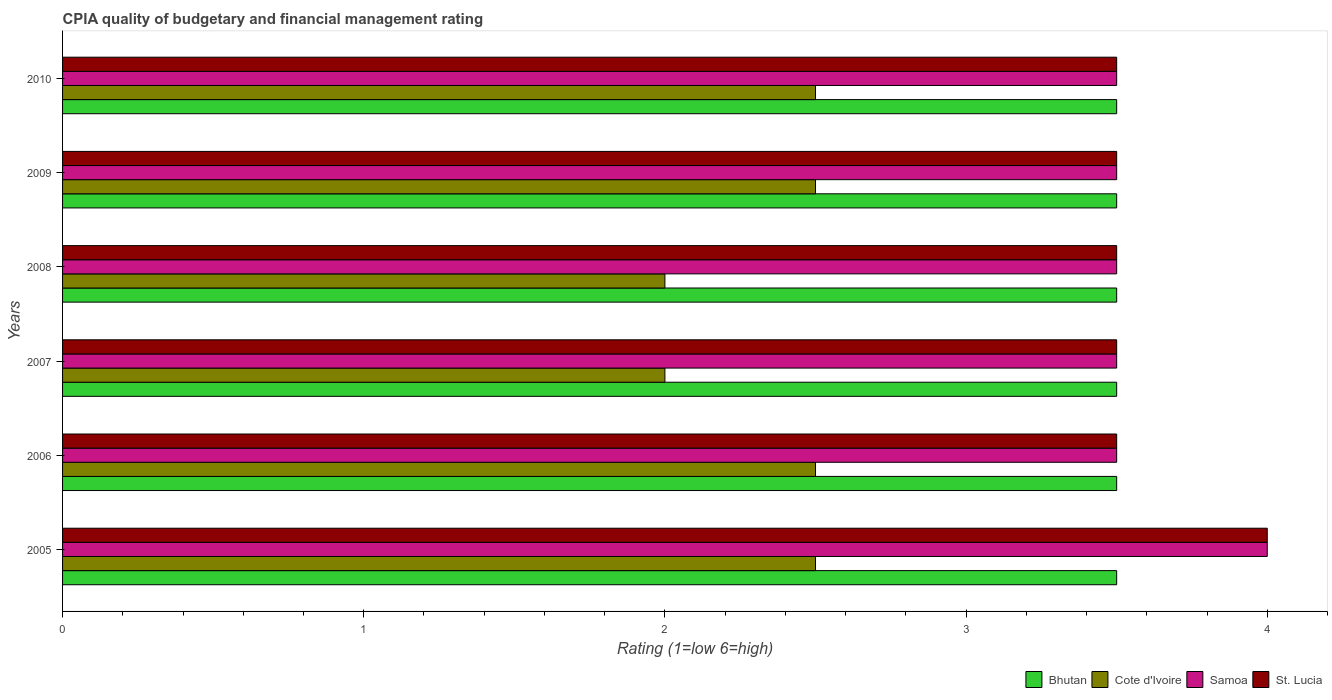How many different coloured bars are there?
Your answer should be compact. 4. How many groups of bars are there?
Provide a short and direct response. 6. Are the number of bars per tick equal to the number of legend labels?
Your answer should be very brief. Yes. Are the number of bars on each tick of the Y-axis equal?
Your answer should be compact. Yes. How many bars are there on the 5th tick from the top?
Your answer should be compact. 4. In how many cases, is the number of bars for a given year not equal to the number of legend labels?
Provide a short and direct response. 0. In which year was the CPIA rating in Cote d'Ivoire maximum?
Your answer should be very brief. 2005. In which year was the CPIA rating in Bhutan minimum?
Your response must be concise. 2005. What is the total CPIA rating in Bhutan in the graph?
Provide a short and direct response. 21. What is the average CPIA rating in St. Lucia per year?
Your response must be concise. 3.58. In how many years, is the CPIA rating in Bhutan greater than 1.2 ?
Keep it short and to the point. 6. What is the ratio of the CPIA rating in Samoa in 2005 to that in 2008?
Keep it short and to the point. 1.14. Is the CPIA rating in Samoa in 2006 less than that in 2008?
Provide a short and direct response. No. Is the difference between the CPIA rating in Bhutan in 2009 and 2010 greater than the difference between the CPIA rating in Samoa in 2009 and 2010?
Give a very brief answer. No. What is the difference between the highest and the second highest CPIA rating in Bhutan?
Your answer should be very brief. 0. In how many years, is the CPIA rating in Samoa greater than the average CPIA rating in Samoa taken over all years?
Offer a very short reply. 1. Is the sum of the CPIA rating in St. Lucia in 2009 and 2010 greater than the maximum CPIA rating in Bhutan across all years?
Give a very brief answer. Yes. What does the 3rd bar from the top in 2009 represents?
Offer a terse response. Cote d'Ivoire. What does the 3rd bar from the bottom in 2006 represents?
Your response must be concise. Samoa. Is it the case that in every year, the sum of the CPIA rating in Samoa and CPIA rating in St. Lucia is greater than the CPIA rating in Bhutan?
Keep it short and to the point. Yes. How many bars are there?
Offer a very short reply. 24. Are all the bars in the graph horizontal?
Your answer should be very brief. Yes. What is the difference between two consecutive major ticks on the X-axis?
Ensure brevity in your answer.  1. Are the values on the major ticks of X-axis written in scientific E-notation?
Ensure brevity in your answer.  No. Where does the legend appear in the graph?
Ensure brevity in your answer.  Bottom right. How many legend labels are there?
Offer a very short reply. 4. What is the title of the graph?
Your response must be concise. CPIA quality of budgetary and financial management rating. Does "Korea (Republic)" appear as one of the legend labels in the graph?
Offer a very short reply. No. What is the Rating (1=low 6=high) in Bhutan in 2005?
Your answer should be very brief. 3.5. What is the Rating (1=low 6=high) in Samoa in 2005?
Your response must be concise. 4. What is the Rating (1=low 6=high) of St. Lucia in 2005?
Keep it short and to the point. 4. What is the Rating (1=low 6=high) in Samoa in 2006?
Give a very brief answer. 3.5. What is the Rating (1=low 6=high) in St. Lucia in 2006?
Provide a succinct answer. 3.5. What is the Rating (1=low 6=high) of Bhutan in 2007?
Keep it short and to the point. 3.5. What is the Rating (1=low 6=high) of Samoa in 2007?
Give a very brief answer. 3.5. What is the Rating (1=low 6=high) in St. Lucia in 2007?
Ensure brevity in your answer.  3.5. What is the Rating (1=low 6=high) in Cote d'Ivoire in 2008?
Provide a succinct answer. 2. What is the Rating (1=low 6=high) of Bhutan in 2010?
Give a very brief answer. 3.5. Across all years, what is the maximum Rating (1=low 6=high) in St. Lucia?
Offer a very short reply. 4. Across all years, what is the minimum Rating (1=low 6=high) of Bhutan?
Give a very brief answer. 3.5. Across all years, what is the minimum Rating (1=low 6=high) in Cote d'Ivoire?
Keep it short and to the point. 2. What is the difference between the Rating (1=low 6=high) in Bhutan in 2005 and that in 2006?
Offer a terse response. 0. What is the difference between the Rating (1=low 6=high) in Cote d'Ivoire in 2005 and that in 2006?
Give a very brief answer. 0. What is the difference between the Rating (1=low 6=high) of Samoa in 2005 and that in 2006?
Provide a short and direct response. 0.5. What is the difference between the Rating (1=low 6=high) of Bhutan in 2005 and that in 2007?
Keep it short and to the point. 0. What is the difference between the Rating (1=low 6=high) in Cote d'Ivoire in 2005 and that in 2007?
Offer a very short reply. 0.5. What is the difference between the Rating (1=low 6=high) of St. Lucia in 2005 and that in 2007?
Offer a very short reply. 0.5. What is the difference between the Rating (1=low 6=high) in Bhutan in 2005 and that in 2008?
Provide a short and direct response. 0. What is the difference between the Rating (1=low 6=high) in St. Lucia in 2005 and that in 2009?
Your answer should be compact. 0.5. What is the difference between the Rating (1=low 6=high) in Bhutan in 2005 and that in 2010?
Ensure brevity in your answer.  0. What is the difference between the Rating (1=low 6=high) in Cote d'Ivoire in 2005 and that in 2010?
Provide a succinct answer. 0. What is the difference between the Rating (1=low 6=high) of Samoa in 2005 and that in 2010?
Your answer should be very brief. 0.5. What is the difference between the Rating (1=low 6=high) in St. Lucia in 2005 and that in 2010?
Ensure brevity in your answer.  0.5. What is the difference between the Rating (1=low 6=high) of Cote d'Ivoire in 2006 and that in 2007?
Ensure brevity in your answer.  0.5. What is the difference between the Rating (1=low 6=high) of Samoa in 2006 and that in 2008?
Offer a terse response. 0. What is the difference between the Rating (1=low 6=high) in St. Lucia in 2006 and that in 2008?
Your answer should be very brief. 0. What is the difference between the Rating (1=low 6=high) of Cote d'Ivoire in 2006 and that in 2009?
Offer a very short reply. 0. What is the difference between the Rating (1=low 6=high) in Samoa in 2006 and that in 2009?
Make the answer very short. 0. What is the difference between the Rating (1=low 6=high) of Bhutan in 2006 and that in 2010?
Offer a terse response. 0. What is the difference between the Rating (1=low 6=high) in Cote d'Ivoire in 2006 and that in 2010?
Offer a very short reply. 0. What is the difference between the Rating (1=low 6=high) of Bhutan in 2007 and that in 2008?
Provide a short and direct response. 0. What is the difference between the Rating (1=low 6=high) in Cote d'Ivoire in 2007 and that in 2008?
Your answer should be very brief. 0. What is the difference between the Rating (1=low 6=high) of Samoa in 2007 and that in 2008?
Provide a succinct answer. 0. What is the difference between the Rating (1=low 6=high) in Cote d'Ivoire in 2008 and that in 2009?
Keep it short and to the point. -0.5. What is the difference between the Rating (1=low 6=high) in Samoa in 2008 and that in 2009?
Keep it short and to the point. 0. What is the difference between the Rating (1=low 6=high) in St. Lucia in 2008 and that in 2009?
Make the answer very short. 0. What is the difference between the Rating (1=low 6=high) of Cote d'Ivoire in 2008 and that in 2010?
Your response must be concise. -0.5. What is the difference between the Rating (1=low 6=high) of Samoa in 2008 and that in 2010?
Offer a terse response. 0. What is the difference between the Rating (1=low 6=high) in Cote d'Ivoire in 2009 and that in 2010?
Provide a succinct answer. 0. What is the difference between the Rating (1=low 6=high) in Bhutan in 2005 and the Rating (1=low 6=high) in Samoa in 2006?
Make the answer very short. 0. What is the difference between the Rating (1=low 6=high) of Samoa in 2005 and the Rating (1=low 6=high) of St. Lucia in 2006?
Your response must be concise. 0.5. What is the difference between the Rating (1=low 6=high) of Bhutan in 2005 and the Rating (1=low 6=high) of Cote d'Ivoire in 2007?
Your answer should be compact. 1.5. What is the difference between the Rating (1=low 6=high) in Bhutan in 2005 and the Rating (1=low 6=high) in St. Lucia in 2007?
Ensure brevity in your answer.  0. What is the difference between the Rating (1=low 6=high) of Bhutan in 2005 and the Rating (1=low 6=high) of Samoa in 2008?
Provide a succinct answer. 0. What is the difference between the Rating (1=low 6=high) of Cote d'Ivoire in 2005 and the Rating (1=low 6=high) of Samoa in 2008?
Your response must be concise. -1. What is the difference between the Rating (1=low 6=high) in Cote d'Ivoire in 2005 and the Rating (1=low 6=high) in St. Lucia in 2008?
Your response must be concise. -1. What is the difference between the Rating (1=low 6=high) of Samoa in 2005 and the Rating (1=low 6=high) of St. Lucia in 2008?
Offer a very short reply. 0.5. What is the difference between the Rating (1=low 6=high) of Bhutan in 2005 and the Rating (1=low 6=high) of Samoa in 2009?
Your answer should be very brief. 0. What is the difference between the Rating (1=low 6=high) of Cote d'Ivoire in 2005 and the Rating (1=low 6=high) of St. Lucia in 2009?
Your answer should be compact. -1. What is the difference between the Rating (1=low 6=high) in Samoa in 2005 and the Rating (1=low 6=high) in St. Lucia in 2009?
Offer a very short reply. 0.5. What is the difference between the Rating (1=low 6=high) of Bhutan in 2005 and the Rating (1=low 6=high) of Cote d'Ivoire in 2010?
Keep it short and to the point. 1. What is the difference between the Rating (1=low 6=high) in Bhutan in 2005 and the Rating (1=low 6=high) in Samoa in 2010?
Provide a short and direct response. 0. What is the difference between the Rating (1=low 6=high) in Bhutan in 2005 and the Rating (1=low 6=high) in St. Lucia in 2010?
Provide a succinct answer. 0. What is the difference between the Rating (1=low 6=high) of Cote d'Ivoire in 2005 and the Rating (1=low 6=high) of Samoa in 2010?
Your answer should be compact. -1. What is the difference between the Rating (1=low 6=high) in Cote d'Ivoire in 2005 and the Rating (1=low 6=high) in St. Lucia in 2010?
Provide a succinct answer. -1. What is the difference between the Rating (1=low 6=high) of Samoa in 2005 and the Rating (1=low 6=high) of St. Lucia in 2010?
Offer a terse response. 0.5. What is the difference between the Rating (1=low 6=high) of Bhutan in 2006 and the Rating (1=low 6=high) of Samoa in 2007?
Provide a short and direct response. 0. What is the difference between the Rating (1=low 6=high) of Samoa in 2006 and the Rating (1=low 6=high) of St. Lucia in 2007?
Keep it short and to the point. 0. What is the difference between the Rating (1=low 6=high) in Bhutan in 2006 and the Rating (1=low 6=high) in Cote d'Ivoire in 2008?
Your answer should be compact. 1.5. What is the difference between the Rating (1=low 6=high) in Bhutan in 2006 and the Rating (1=low 6=high) in St. Lucia in 2008?
Your answer should be compact. 0. What is the difference between the Rating (1=low 6=high) in Samoa in 2006 and the Rating (1=low 6=high) in St. Lucia in 2008?
Ensure brevity in your answer.  0. What is the difference between the Rating (1=low 6=high) of Bhutan in 2006 and the Rating (1=low 6=high) of Samoa in 2009?
Your answer should be very brief. 0. What is the difference between the Rating (1=low 6=high) of Cote d'Ivoire in 2006 and the Rating (1=low 6=high) of Samoa in 2009?
Your answer should be compact. -1. What is the difference between the Rating (1=low 6=high) in Cote d'Ivoire in 2006 and the Rating (1=low 6=high) in St. Lucia in 2009?
Make the answer very short. -1. What is the difference between the Rating (1=low 6=high) of Samoa in 2006 and the Rating (1=low 6=high) of St. Lucia in 2009?
Offer a terse response. 0. What is the difference between the Rating (1=low 6=high) in Cote d'Ivoire in 2006 and the Rating (1=low 6=high) in Samoa in 2010?
Ensure brevity in your answer.  -1. What is the difference between the Rating (1=low 6=high) in Cote d'Ivoire in 2006 and the Rating (1=low 6=high) in St. Lucia in 2010?
Keep it short and to the point. -1. What is the difference between the Rating (1=low 6=high) of Bhutan in 2007 and the Rating (1=low 6=high) of Cote d'Ivoire in 2008?
Your answer should be very brief. 1.5. What is the difference between the Rating (1=low 6=high) in Bhutan in 2007 and the Rating (1=low 6=high) in Samoa in 2008?
Offer a terse response. 0. What is the difference between the Rating (1=low 6=high) of Bhutan in 2007 and the Rating (1=low 6=high) of St. Lucia in 2008?
Your answer should be compact. 0. What is the difference between the Rating (1=low 6=high) in Cote d'Ivoire in 2007 and the Rating (1=low 6=high) in Samoa in 2008?
Your response must be concise. -1.5. What is the difference between the Rating (1=low 6=high) in Samoa in 2007 and the Rating (1=low 6=high) in St. Lucia in 2008?
Make the answer very short. 0. What is the difference between the Rating (1=low 6=high) of Cote d'Ivoire in 2007 and the Rating (1=low 6=high) of Samoa in 2009?
Offer a very short reply. -1.5. What is the difference between the Rating (1=low 6=high) of Bhutan in 2007 and the Rating (1=low 6=high) of Samoa in 2010?
Keep it short and to the point. 0. What is the difference between the Rating (1=low 6=high) in Samoa in 2007 and the Rating (1=low 6=high) in St. Lucia in 2010?
Your answer should be very brief. 0. What is the difference between the Rating (1=low 6=high) in Bhutan in 2008 and the Rating (1=low 6=high) in Cote d'Ivoire in 2009?
Offer a very short reply. 1. What is the difference between the Rating (1=low 6=high) in Bhutan in 2008 and the Rating (1=low 6=high) in St. Lucia in 2009?
Your answer should be very brief. 0. What is the difference between the Rating (1=low 6=high) in Cote d'Ivoire in 2008 and the Rating (1=low 6=high) in Samoa in 2009?
Provide a succinct answer. -1.5. What is the difference between the Rating (1=low 6=high) of Bhutan in 2008 and the Rating (1=low 6=high) of St. Lucia in 2010?
Provide a short and direct response. 0. What is the difference between the Rating (1=low 6=high) of Cote d'Ivoire in 2008 and the Rating (1=low 6=high) of Samoa in 2010?
Your answer should be very brief. -1.5. What is the difference between the Rating (1=low 6=high) of Bhutan in 2009 and the Rating (1=low 6=high) of Samoa in 2010?
Offer a terse response. 0. What is the difference between the Rating (1=low 6=high) of Bhutan in 2009 and the Rating (1=low 6=high) of St. Lucia in 2010?
Provide a succinct answer. 0. What is the difference between the Rating (1=low 6=high) of Samoa in 2009 and the Rating (1=low 6=high) of St. Lucia in 2010?
Make the answer very short. 0. What is the average Rating (1=low 6=high) in Bhutan per year?
Keep it short and to the point. 3.5. What is the average Rating (1=low 6=high) of Cote d'Ivoire per year?
Keep it short and to the point. 2.33. What is the average Rating (1=low 6=high) of Samoa per year?
Ensure brevity in your answer.  3.58. What is the average Rating (1=low 6=high) of St. Lucia per year?
Offer a terse response. 3.58. In the year 2005, what is the difference between the Rating (1=low 6=high) of Bhutan and Rating (1=low 6=high) of Cote d'Ivoire?
Provide a succinct answer. 1. In the year 2005, what is the difference between the Rating (1=low 6=high) of Bhutan and Rating (1=low 6=high) of St. Lucia?
Your answer should be very brief. -0.5. In the year 2006, what is the difference between the Rating (1=low 6=high) in Bhutan and Rating (1=low 6=high) in Samoa?
Provide a succinct answer. 0. In the year 2006, what is the difference between the Rating (1=low 6=high) in Bhutan and Rating (1=low 6=high) in St. Lucia?
Your response must be concise. 0. In the year 2007, what is the difference between the Rating (1=low 6=high) of Bhutan and Rating (1=low 6=high) of Cote d'Ivoire?
Provide a short and direct response. 1.5. In the year 2007, what is the difference between the Rating (1=low 6=high) of Bhutan and Rating (1=low 6=high) of Samoa?
Provide a short and direct response. 0. In the year 2007, what is the difference between the Rating (1=low 6=high) in Cote d'Ivoire and Rating (1=low 6=high) in St. Lucia?
Make the answer very short. -1.5. In the year 2007, what is the difference between the Rating (1=low 6=high) in Samoa and Rating (1=low 6=high) in St. Lucia?
Offer a very short reply. 0. In the year 2008, what is the difference between the Rating (1=low 6=high) in Bhutan and Rating (1=low 6=high) in St. Lucia?
Your response must be concise. 0. In the year 2008, what is the difference between the Rating (1=low 6=high) of Cote d'Ivoire and Rating (1=low 6=high) of Samoa?
Keep it short and to the point. -1.5. In the year 2010, what is the difference between the Rating (1=low 6=high) of Bhutan and Rating (1=low 6=high) of Samoa?
Offer a terse response. 0. In the year 2010, what is the difference between the Rating (1=low 6=high) in Bhutan and Rating (1=low 6=high) in St. Lucia?
Your answer should be very brief. 0. In the year 2010, what is the difference between the Rating (1=low 6=high) in Cote d'Ivoire and Rating (1=low 6=high) in Samoa?
Offer a terse response. -1. In the year 2010, what is the difference between the Rating (1=low 6=high) of Cote d'Ivoire and Rating (1=low 6=high) of St. Lucia?
Keep it short and to the point. -1. What is the ratio of the Rating (1=low 6=high) of St. Lucia in 2005 to that in 2007?
Offer a terse response. 1.14. What is the ratio of the Rating (1=low 6=high) of Bhutan in 2005 to that in 2008?
Provide a succinct answer. 1. What is the ratio of the Rating (1=low 6=high) of Cote d'Ivoire in 2005 to that in 2008?
Provide a succinct answer. 1.25. What is the ratio of the Rating (1=low 6=high) in Samoa in 2005 to that in 2008?
Your answer should be compact. 1.14. What is the ratio of the Rating (1=low 6=high) of Bhutan in 2005 to that in 2009?
Offer a terse response. 1. What is the ratio of the Rating (1=low 6=high) in Cote d'Ivoire in 2005 to that in 2009?
Keep it short and to the point. 1. What is the ratio of the Rating (1=low 6=high) in Samoa in 2005 to that in 2009?
Offer a terse response. 1.14. What is the ratio of the Rating (1=low 6=high) in Bhutan in 2005 to that in 2010?
Ensure brevity in your answer.  1. What is the ratio of the Rating (1=low 6=high) in Cote d'Ivoire in 2005 to that in 2010?
Provide a short and direct response. 1. What is the ratio of the Rating (1=low 6=high) in Samoa in 2005 to that in 2010?
Your answer should be compact. 1.14. What is the ratio of the Rating (1=low 6=high) in Bhutan in 2006 to that in 2007?
Provide a succinct answer. 1. What is the ratio of the Rating (1=low 6=high) of Cote d'Ivoire in 2006 to that in 2007?
Offer a very short reply. 1.25. What is the ratio of the Rating (1=low 6=high) of Samoa in 2006 to that in 2007?
Your response must be concise. 1. What is the ratio of the Rating (1=low 6=high) of St. Lucia in 2006 to that in 2007?
Provide a succinct answer. 1. What is the ratio of the Rating (1=low 6=high) in Bhutan in 2006 to that in 2008?
Ensure brevity in your answer.  1. What is the ratio of the Rating (1=low 6=high) of Samoa in 2006 to that in 2008?
Your answer should be compact. 1. What is the ratio of the Rating (1=low 6=high) of Bhutan in 2006 to that in 2009?
Provide a short and direct response. 1. What is the ratio of the Rating (1=low 6=high) in Samoa in 2006 to that in 2009?
Make the answer very short. 1. What is the ratio of the Rating (1=low 6=high) of Bhutan in 2006 to that in 2010?
Offer a very short reply. 1. What is the ratio of the Rating (1=low 6=high) of Bhutan in 2007 to that in 2008?
Provide a succinct answer. 1. What is the ratio of the Rating (1=low 6=high) of Cote d'Ivoire in 2007 to that in 2009?
Your answer should be very brief. 0.8. What is the ratio of the Rating (1=low 6=high) of Samoa in 2007 to that in 2009?
Provide a succinct answer. 1. What is the ratio of the Rating (1=low 6=high) in St. Lucia in 2007 to that in 2009?
Your answer should be very brief. 1. What is the ratio of the Rating (1=low 6=high) in Bhutan in 2007 to that in 2010?
Your response must be concise. 1. What is the ratio of the Rating (1=low 6=high) in Cote d'Ivoire in 2007 to that in 2010?
Your answer should be compact. 0.8. What is the ratio of the Rating (1=low 6=high) in Samoa in 2007 to that in 2010?
Your answer should be compact. 1. What is the ratio of the Rating (1=low 6=high) of St. Lucia in 2007 to that in 2010?
Your answer should be compact. 1. What is the ratio of the Rating (1=low 6=high) in Samoa in 2008 to that in 2009?
Give a very brief answer. 1. What is the ratio of the Rating (1=low 6=high) of St. Lucia in 2008 to that in 2009?
Provide a succinct answer. 1. What is the ratio of the Rating (1=low 6=high) in Samoa in 2008 to that in 2010?
Offer a terse response. 1. What is the difference between the highest and the second highest Rating (1=low 6=high) in Bhutan?
Keep it short and to the point. 0. What is the difference between the highest and the second highest Rating (1=low 6=high) of Cote d'Ivoire?
Give a very brief answer. 0. What is the difference between the highest and the lowest Rating (1=low 6=high) of Samoa?
Your answer should be compact. 0.5. 